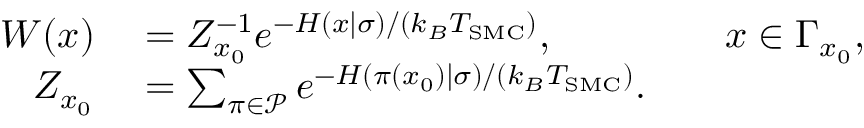<formula> <loc_0><loc_0><loc_500><loc_500>\begin{array} { r l r l } { W ( x ) } & = Z _ { x _ { 0 } } ^ { - 1 } e ^ { - H ( x | \sigma ) / ( k _ { B } T _ { S M C } ) } , } & x \in \Gamma _ { x _ { 0 } } , } \\ { Z _ { x _ { 0 } } } & = \sum _ { \pi \in \mathcal { P } } e ^ { - H ( \pi ( x _ { 0 } ) | \sigma ) / ( k _ { B } T _ { S M C } ) } . } \end{array}</formula> 